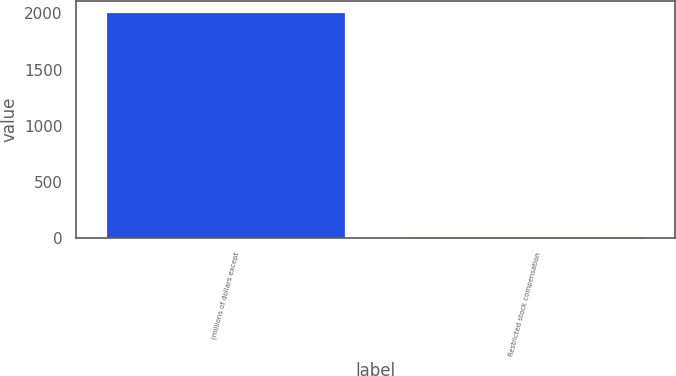Convert chart. <chart><loc_0><loc_0><loc_500><loc_500><bar_chart><fcel>(millions of dollars except<fcel>Restricted stock compensation<nl><fcel>2014<fcel>15.1<nl></chart> 